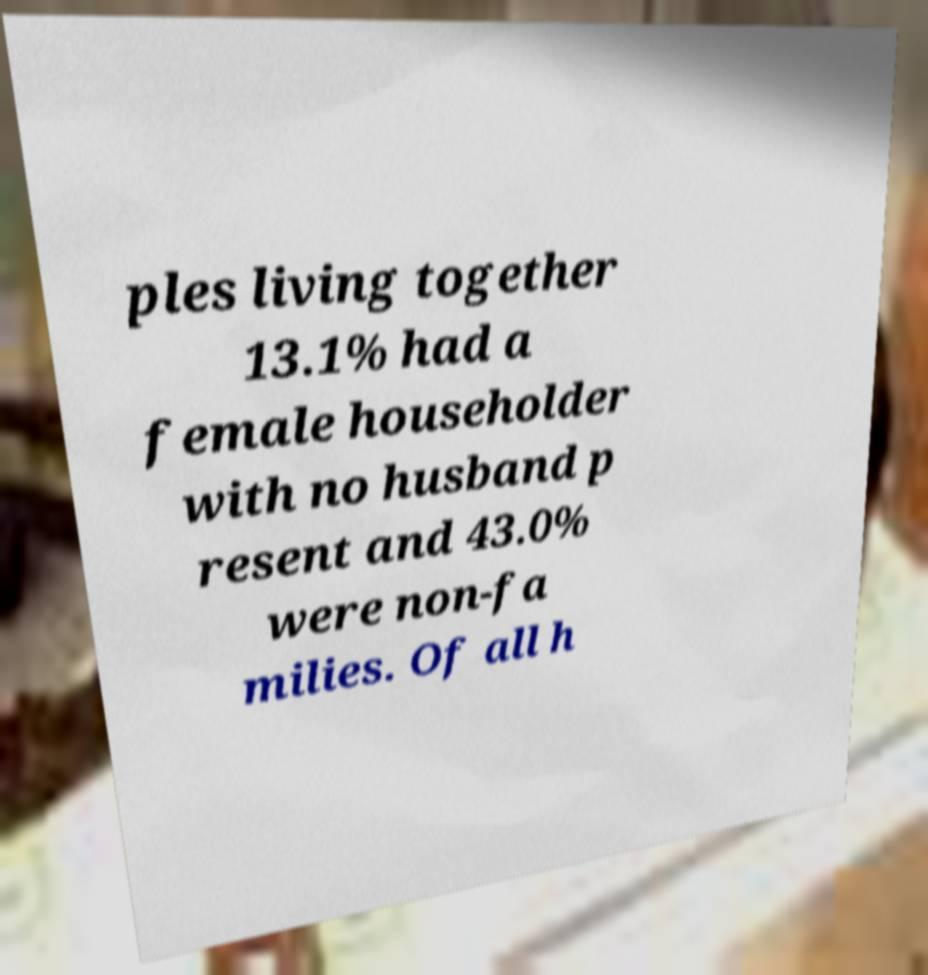Could you extract and type out the text from this image? ples living together 13.1% had a female householder with no husband p resent and 43.0% were non-fa milies. Of all h 